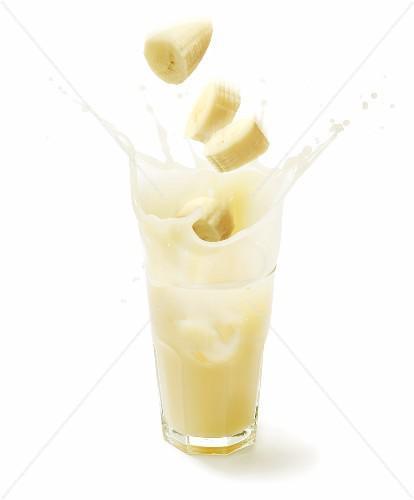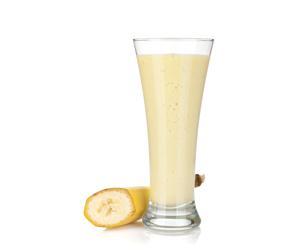The first image is the image on the left, the second image is the image on the right. Evaluate the accuracy of this statement regarding the images: "All the bananas are cut.". Is it true? Answer yes or no. Yes. 